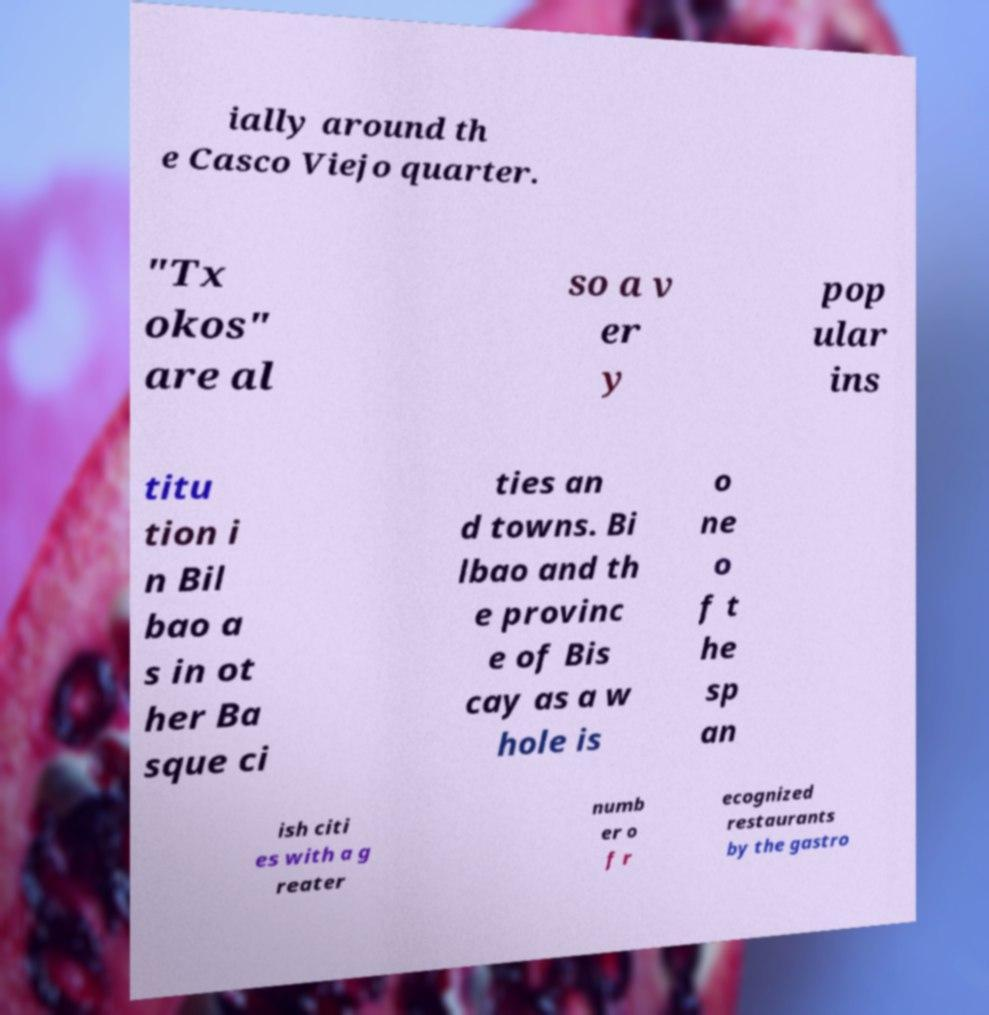Could you extract and type out the text from this image? ially around th e Casco Viejo quarter. "Tx okos" are al so a v er y pop ular ins titu tion i n Bil bao a s in ot her Ba sque ci ties an d towns. Bi lbao and th e provinc e of Bis cay as a w hole is o ne o f t he sp an ish citi es with a g reater numb er o f r ecognized restaurants by the gastro 